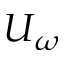Convert formula to latex. <formula><loc_0><loc_0><loc_500><loc_500>U _ { \omega }</formula> 